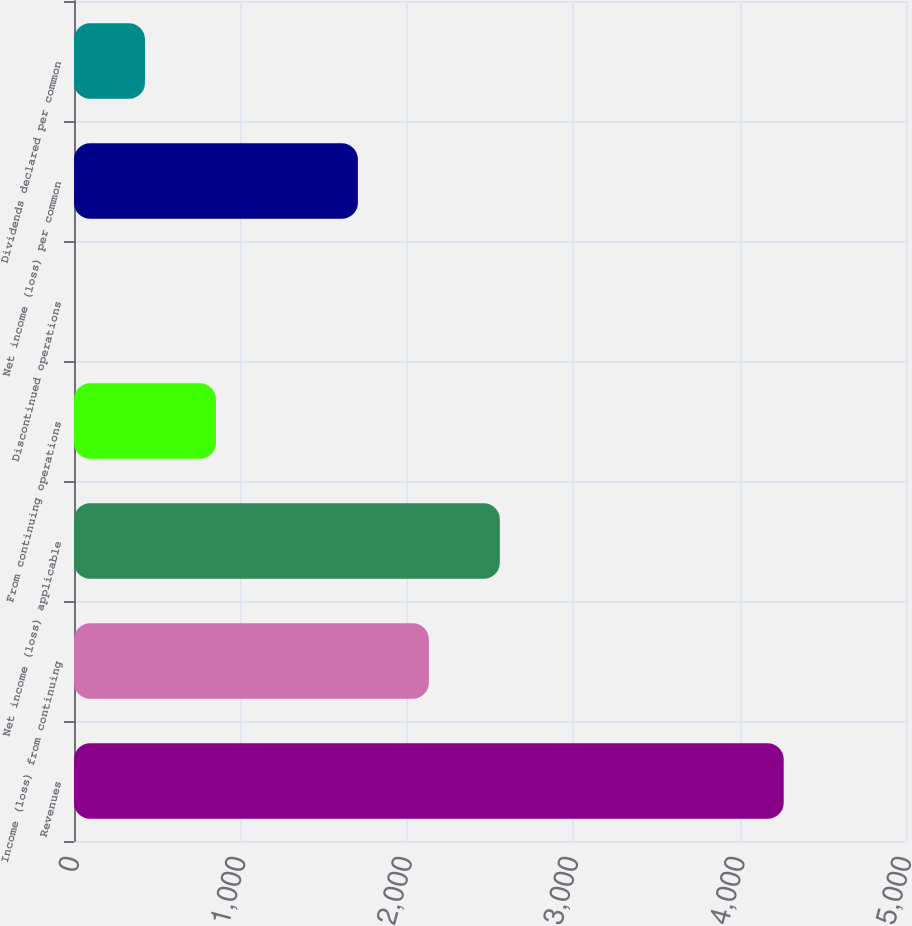Convert chart to OTSL. <chart><loc_0><loc_0><loc_500><loc_500><bar_chart><fcel>Revenues<fcel>Income (loss) from continuing<fcel>Net income (loss) applicable<fcel>From continuing operations<fcel>Discontinued operations<fcel>Net income (loss) per common<fcel>Dividends declared per common<nl><fcel>4265<fcel>2132.55<fcel>2559.04<fcel>853.08<fcel>0.1<fcel>1706.06<fcel>426.59<nl></chart> 